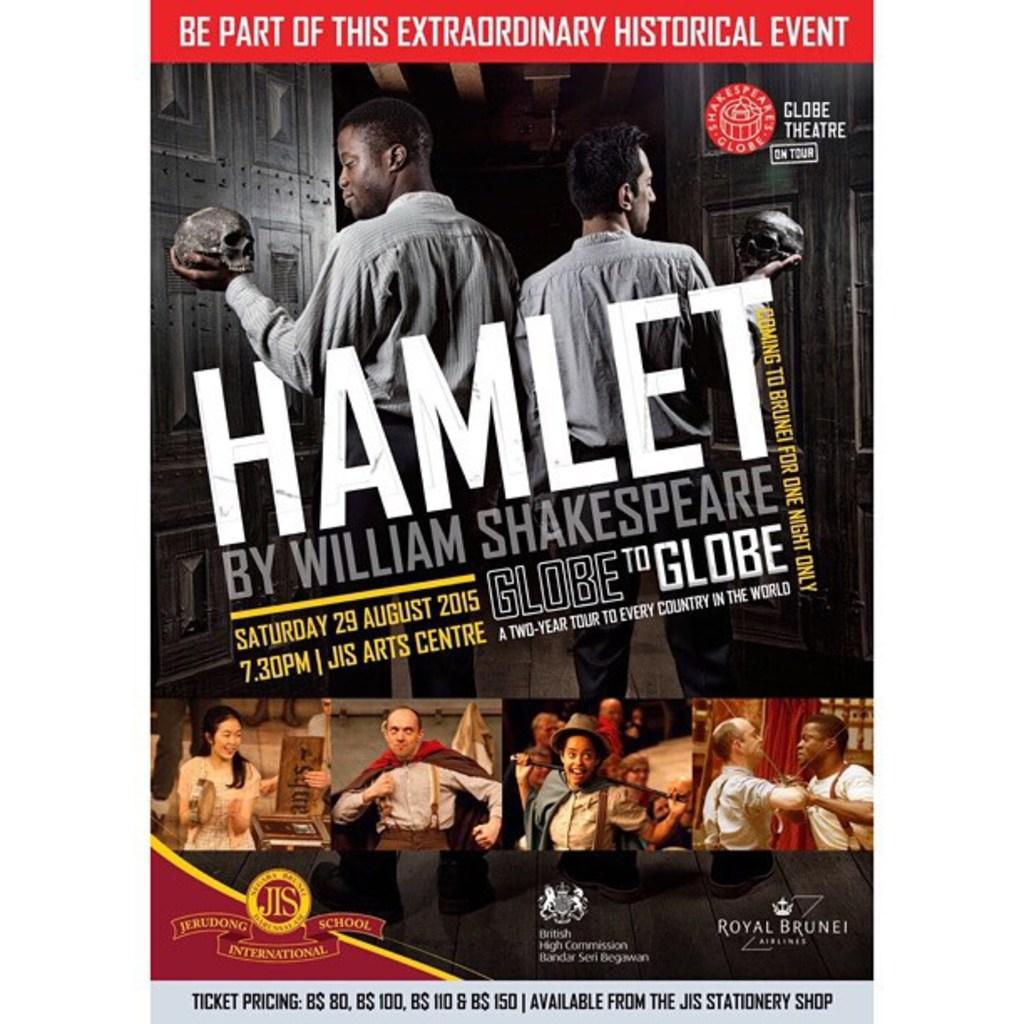What is present on the poster in the image? The poster contains images and text. Can you describe the poster's appearance? The poster is on a white background. What type of dinner is being served in the image? There is no dinner present in the image; it only features a poster with images and text on a white background. What word is being emphasized in the image? There is no specific word being emphasized in the image, as it only contains a poster with images and text on a white background. 